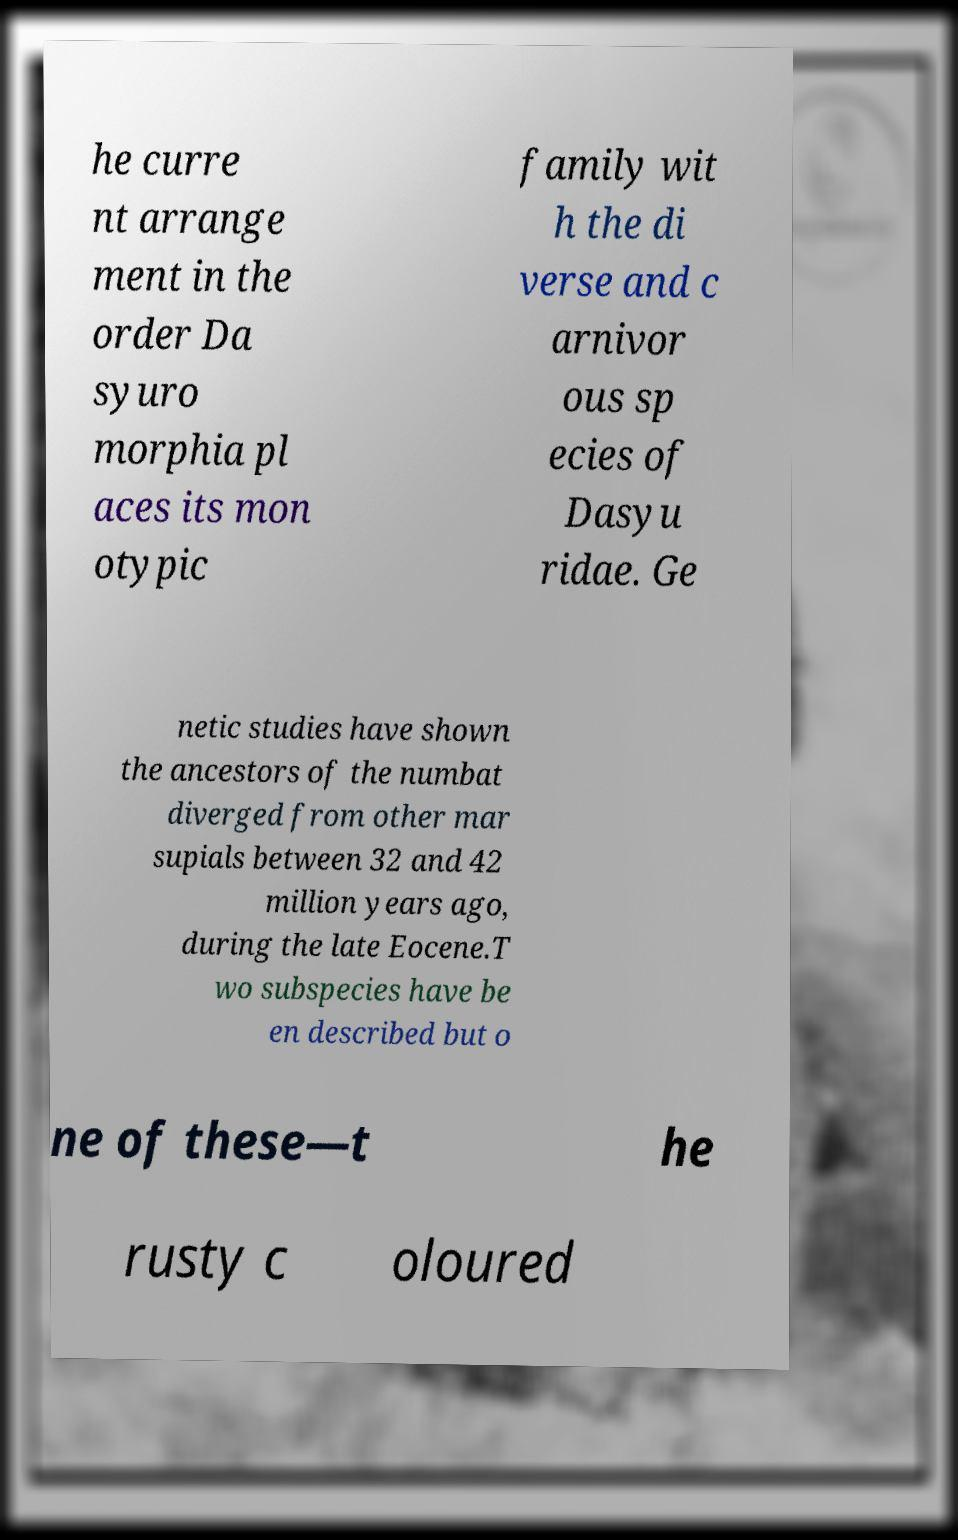What messages or text are displayed in this image? I need them in a readable, typed format. he curre nt arrange ment in the order Da syuro morphia pl aces its mon otypic family wit h the di verse and c arnivor ous sp ecies of Dasyu ridae. Ge netic studies have shown the ancestors of the numbat diverged from other mar supials between 32 and 42 million years ago, during the late Eocene.T wo subspecies have be en described but o ne of these—t he rusty c oloured 